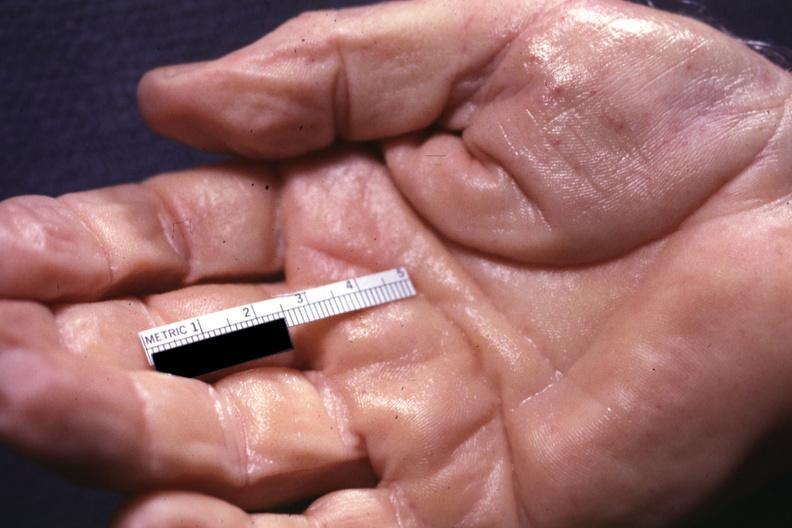what are present?
Answer the question using a single word or phrase. No 